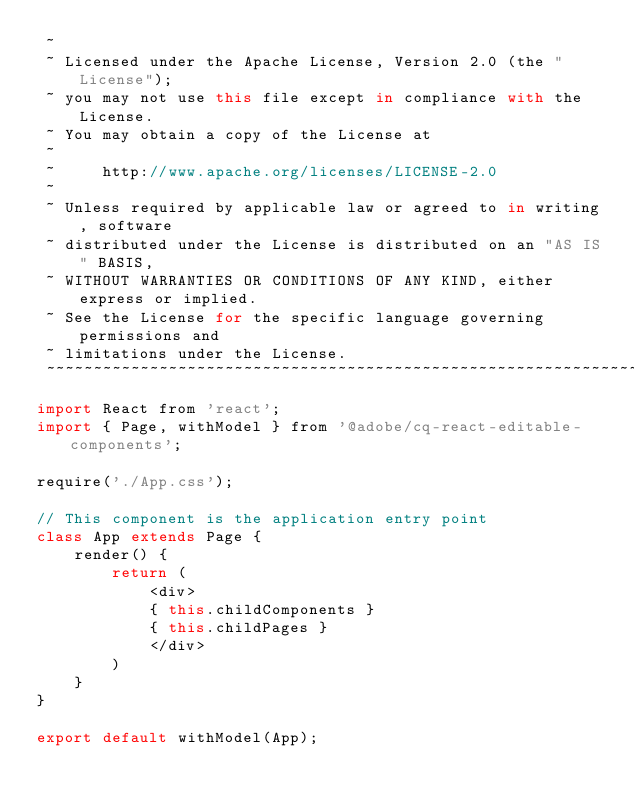<code> <loc_0><loc_0><loc_500><loc_500><_JavaScript_> ~
 ~ Licensed under the Apache License, Version 2.0 (the "License");
 ~ you may not use this file except in compliance with the License.
 ~ You may obtain a copy of the License at
 ~
 ~     http://www.apache.org/licenses/LICENSE-2.0
 ~
 ~ Unless required by applicable law or agreed to in writing, software
 ~ distributed under the License is distributed on an "AS IS" BASIS,
 ~ WITHOUT WARRANTIES OR CONDITIONS OF ANY KIND, either express or implied.
 ~ See the License for the specific language governing permissions and
 ~ limitations under the License.
 ~~~~~~~~~~~~~~~~~~~~~~~~~~~~~~~~~~~~~~~~~~~~~~~~~~~~~~~~~~~~~~~~~~~~~~~~~~~~~*/
import React from 'react';
import { Page, withModel } from '@adobe/cq-react-editable-components';

require('./App.css');

// This component is the application entry point
class App extends Page {
    render() {
        return (
            <div>
            { this.childComponents }
            { this.childPages }
            </div>
        )
    }
}

export default withModel(App);
</code> 